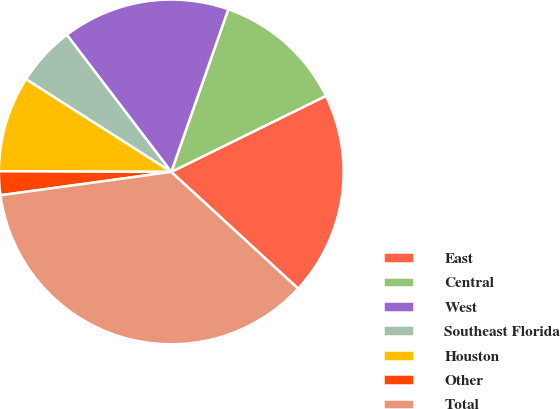Convert chart to OTSL. <chart><loc_0><loc_0><loc_500><loc_500><pie_chart><fcel>East<fcel>Central<fcel>West<fcel>Southeast Florida<fcel>Houston<fcel>Other<fcel>Total<nl><fcel>19.11%<fcel>12.36%<fcel>15.73%<fcel>5.6%<fcel>8.98%<fcel>2.22%<fcel>36.0%<nl></chart> 